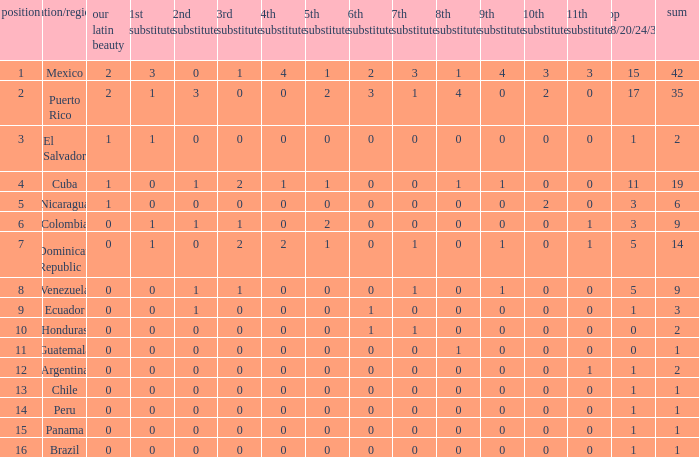What is the 3rd runner-up of the country with more than 0 9th runner-up, an 11th runner-up of 0, and the 1st runner-up greater than 0? None. 